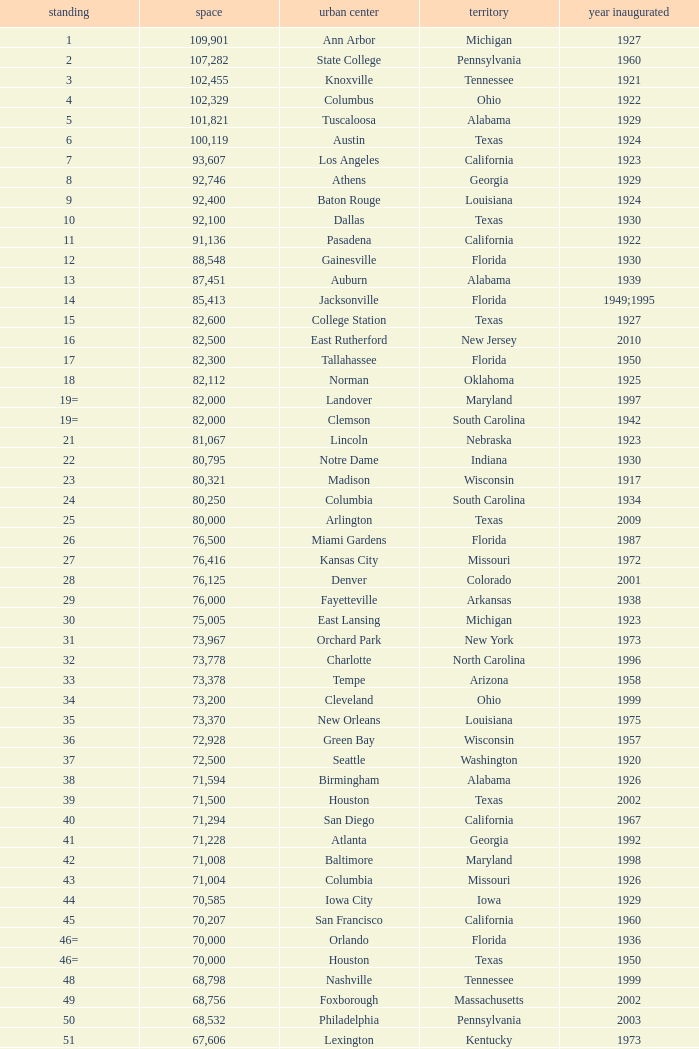What is the lowest capacity for 1903? 30323.0. 